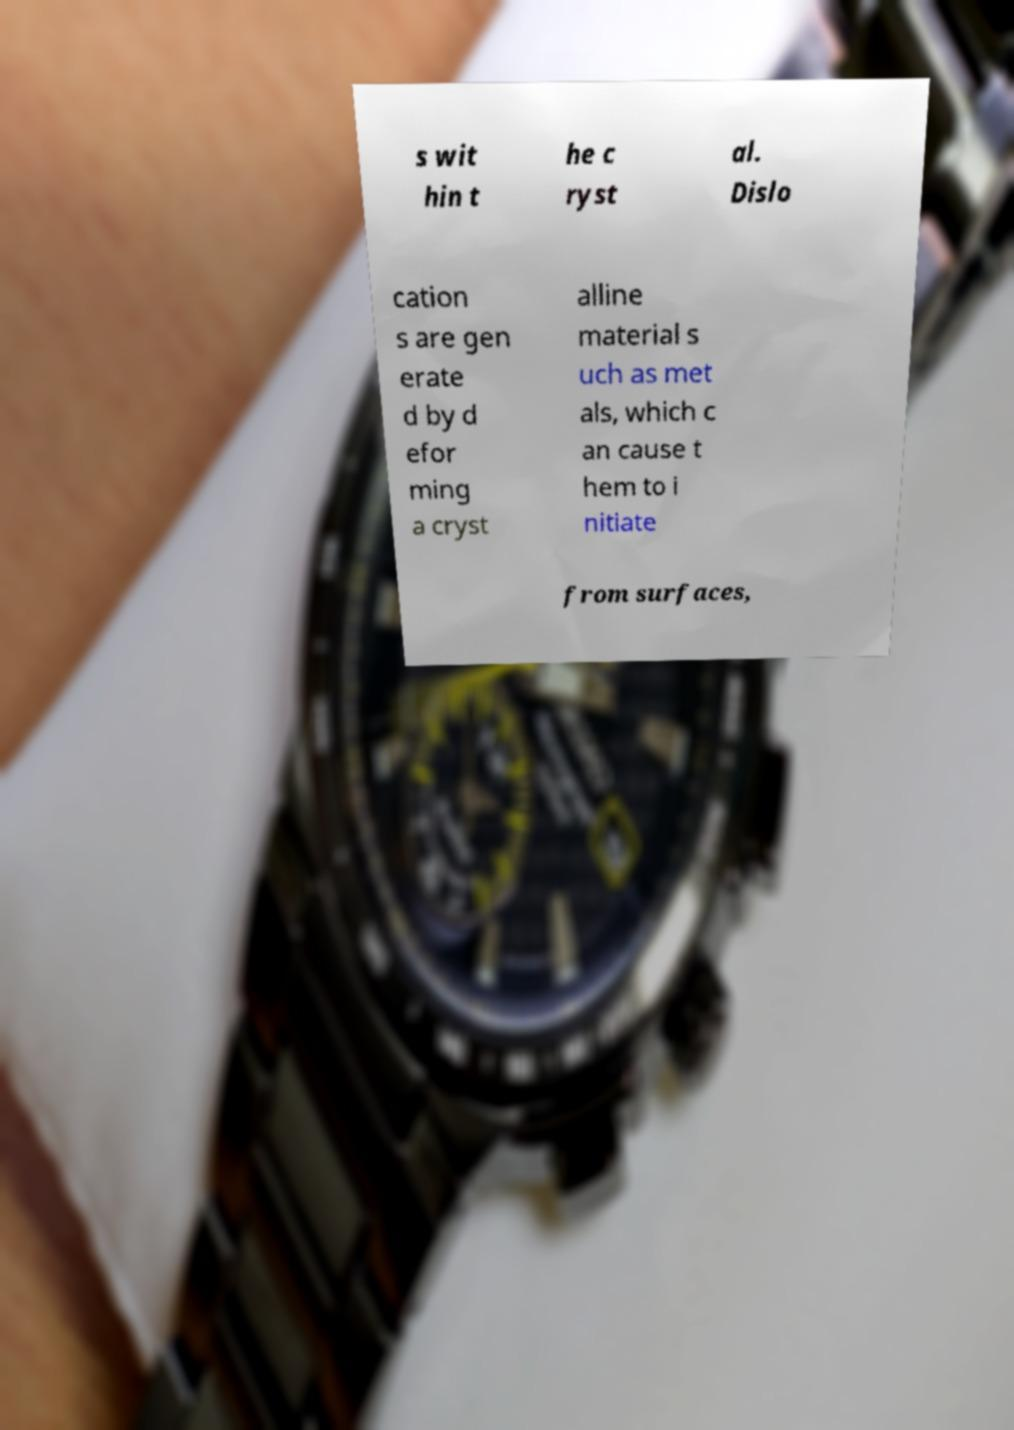There's text embedded in this image that I need extracted. Can you transcribe it verbatim? s wit hin t he c ryst al. Dislo cation s are gen erate d by d efor ming a cryst alline material s uch as met als, which c an cause t hem to i nitiate from surfaces, 